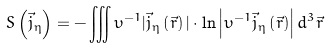Convert formula to latex. <formula><loc_0><loc_0><loc_500><loc_500>S \left ( { \vec { j } _ { \eta } } \right ) = - \iiint \upsilon ^ { - 1 } | \vec { j } _ { \eta } \left ( { \vec { r } } \right ) | \cdot \ln \left | \upsilon ^ { - 1 } \vec { j } _ { \eta } \left ( { \vec { r } } \right ) \right | d ^ { 3 } \vec { r }</formula> 